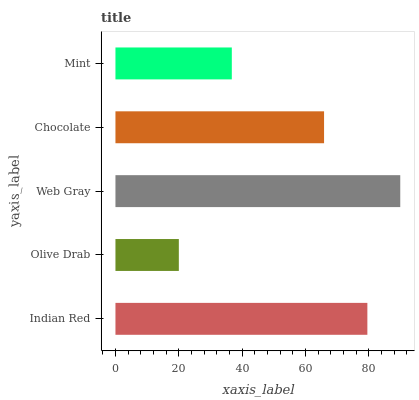Is Olive Drab the minimum?
Answer yes or no. Yes. Is Web Gray the maximum?
Answer yes or no. Yes. Is Web Gray the minimum?
Answer yes or no. No. Is Olive Drab the maximum?
Answer yes or no. No. Is Web Gray greater than Olive Drab?
Answer yes or no. Yes. Is Olive Drab less than Web Gray?
Answer yes or no. Yes. Is Olive Drab greater than Web Gray?
Answer yes or no. No. Is Web Gray less than Olive Drab?
Answer yes or no. No. Is Chocolate the high median?
Answer yes or no. Yes. Is Chocolate the low median?
Answer yes or no. Yes. Is Mint the high median?
Answer yes or no. No. Is Olive Drab the low median?
Answer yes or no. No. 